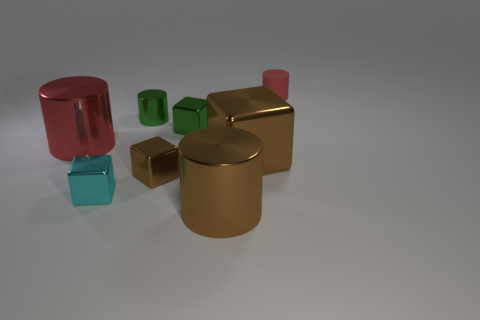Subtract all big red cylinders. How many cylinders are left? 3 Add 1 red shiny cylinders. How many objects exist? 9 Subtract all brown cylinders. How many cylinders are left? 3 Subtract 2 cylinders. How many cylinders are left? 2 Subtract all cyan cylinders. How many gray blocks are left? 0 Subtract all brown cylinders. Subtract all blue spheres. How many cylinders are left? 3 Subtract all small red cylinders. Subtract all cyan metallic cubes. How many objects are left? 6 Add 8 rubber objects. How many rubber objects are left? 9 Add 6 large gray balls. How many large gray balls exist? 6 Subtract 1 red cylinders. How many objects are left? 7 